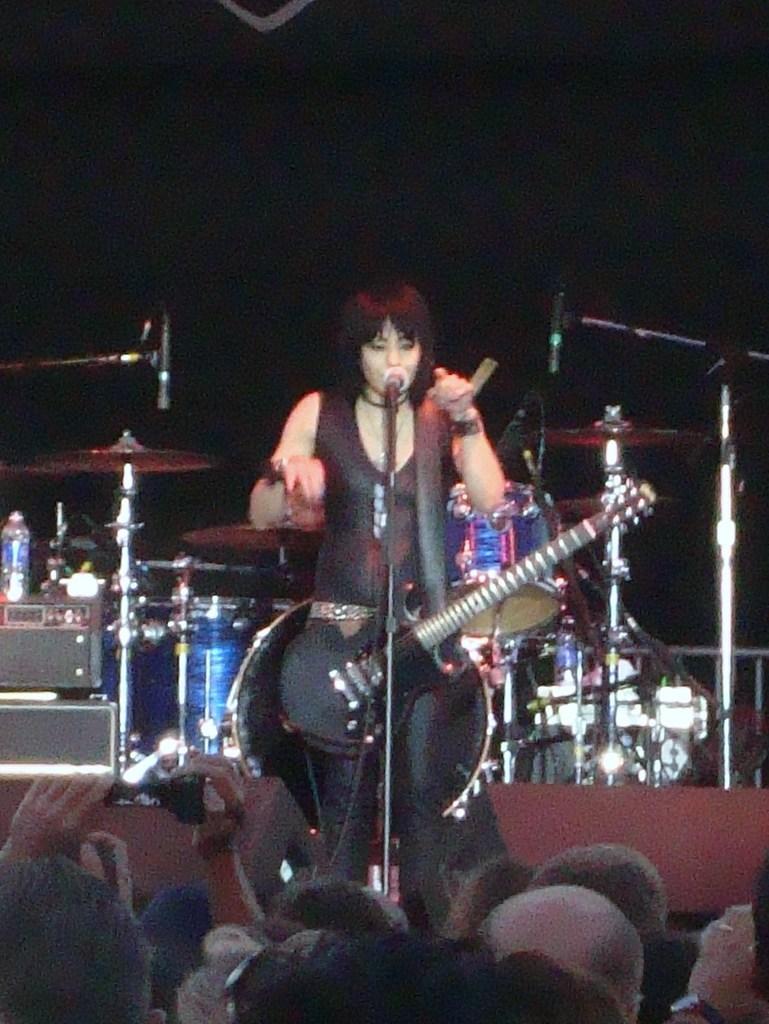Could you give a brief overview of what you see in this image? This image is clicked in a concert. There is woman singing and playing guitar. In the background there is a band setup. At the bottom there are many people. 